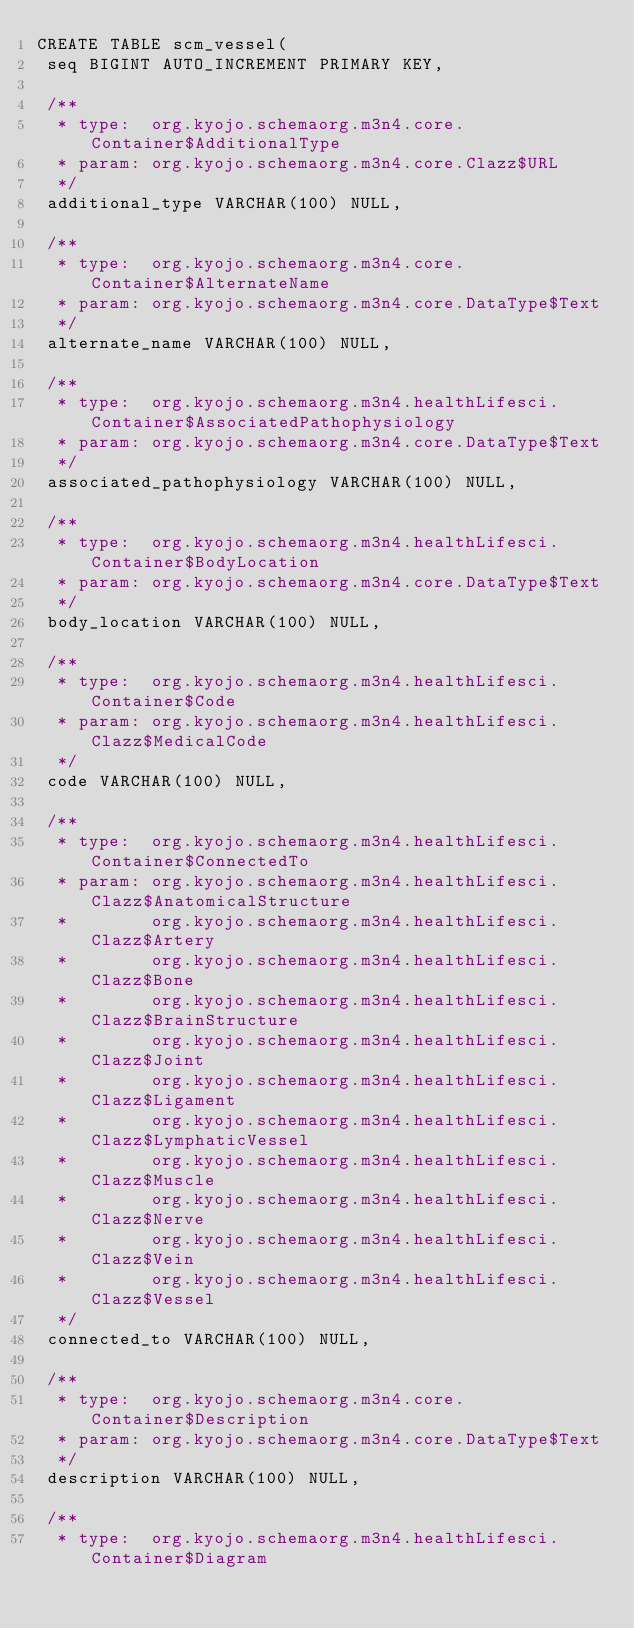Convert code to text. <code><loc_0><loc_0><loc_500><loc_500><_SQL_>CREATE TABLE scm_vessel(
 seq BIGINT AUTO_INCREMENT PRIMARY KEY,

 /**
  * type:  org.kyojo.schemaorg.m3n4.core.Container$AdditionalType
  * param: org.kyojo.schemaorg.m3n4.core.Clazz$URL
  */
 additional_type VARCHAR(100) NULL,

 /**
  * type:  org.kyojo.schemaorg.m3n4.core.Container$AlternateName
  * param: org.kyojo.schemaorg.m3n4.core.DataType$Text
  */
 alternate_name VARCHAR(100) NULL,

 /**
  * type:  org.kyojo.schemaorg.m3n4.healthLifesci.Container$AssociatedPathophysiology
  * param: org.kyojo.schemaorg.m3n4.core.DataType$Text
  */
 associated_pathophysiology VARCHAR(100) NULL,

 /**
  * type:  org.kyojo.schemaorg.m3n4.healthLifesci.Container$BodyLocation
  * param: org.kyojo.schemaorg.m3n4.core.DataType$Text
  */
 body_location VARCHAR(100) NULL,

 /**
  * type:  org.kyojo.schemaorg.m3n4.healthLifesci.Container$Code
  * param: org.kyojo.schemaorg.m3n4.healthLifesci.Clazz$MedicalCode
  */
 code VARCHAR(100) NULL,

 /**
  * type:  org.kyojo.schemaorg.m3n4.healthLifesci.Container$ConnectedTo
  * param: org.kyojo.schemaorg.m3n4.healthLifesci.Clazz$AnatomicalStructure
  *        org.kyojo.schemaorg.m3n4.healthLifesci.Clazz$Artery
  *        org.kyojo.schemaorg.m3n4.healthLifesci.Clazz$Bone
  *        org.kyojo.schemaorg.m3n4.healthLifesci.Clazz$BrainStructure
  *        org.kyojo.schemaorg.m3n4.healthLifesci.Clazz$Joint
  *        org.kyojo.schemaorg.m3n4.healthLifesci.Clazz$Ligament
  *        org.kyojo.schemaorg.m3n4.healthLifesci.Clazz$LymphaticVessel
  *        org.kyojo.schemaorg.m3n4.healthLifesci.Clazz$Muscle
  *        org.kyojo.schemaorg.m3n4.healthLifesci.Clazz$Nerve
  *        org.kyojo.schemaorg.m3n4.healthLifesci.Clazz$Vein
  *        org.kyojo.schemaorg.m3n4.healthLifesci.Clazz$Vessel
  */
 connected_to VARCHAR(100) NULL,

 /**
  * type:  org.kyojo.schemaorg.m3n4.core.Container$Description
  * param: org.kyojo.schemaorg.m3n4.core.DataType$Text
  */
 description VARCHAR(100) NULL,

 /**
  * type:  org.kyojo.schemaorg.m3n4.healthLifesci.Container$Diagram</code> 